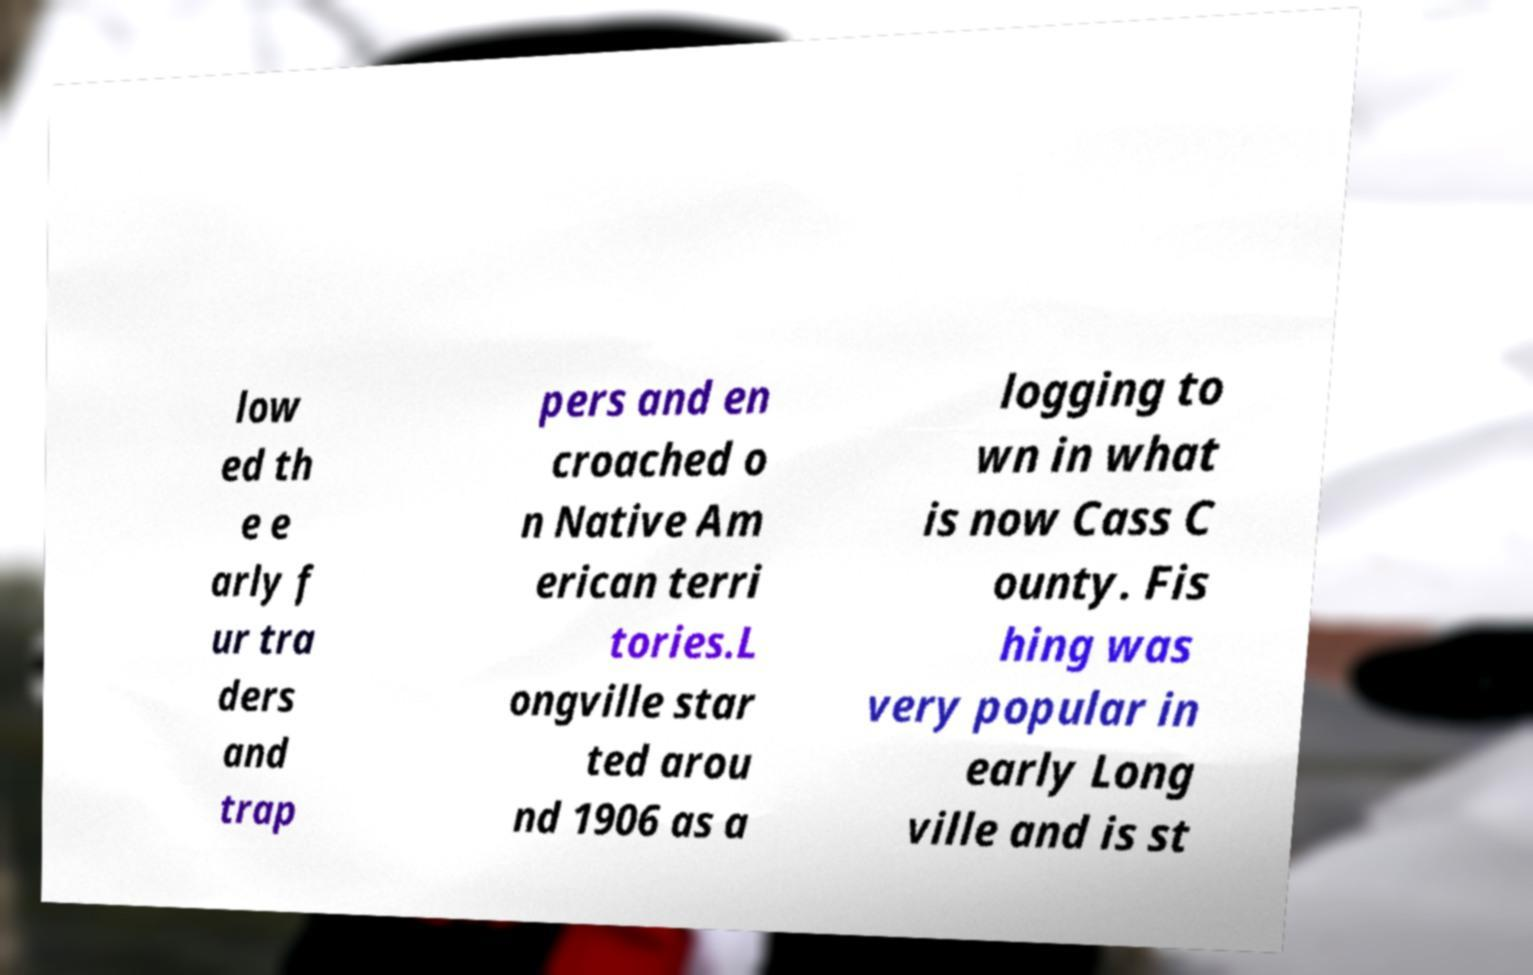Please read and relay the text visible in this image. What does it say? low ed th e e arly f ur tra ders and trap pers and en croached o n Native Am erican terri tories.L ongville star ted arou nd 1906 as a logging to wn in what is now Cass C ounty. Fis hing was very popular in early Long ville and is st 